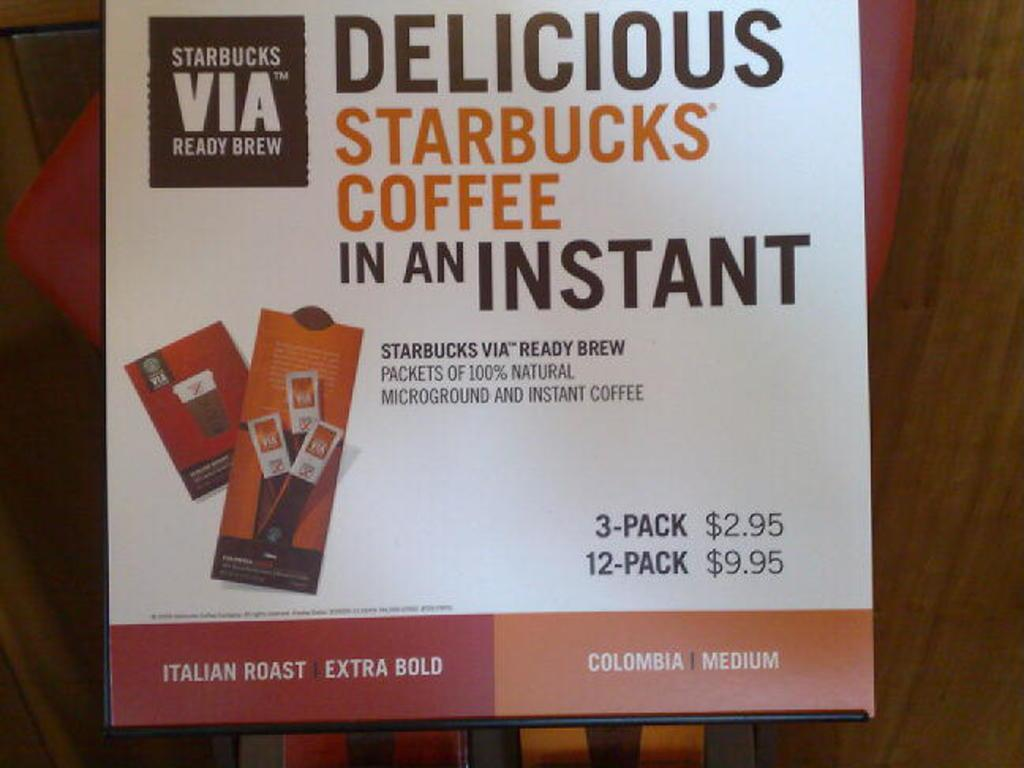<image>
Summarize the visual content of the image. a board that says 'starbucks coffee in an instant' on it 